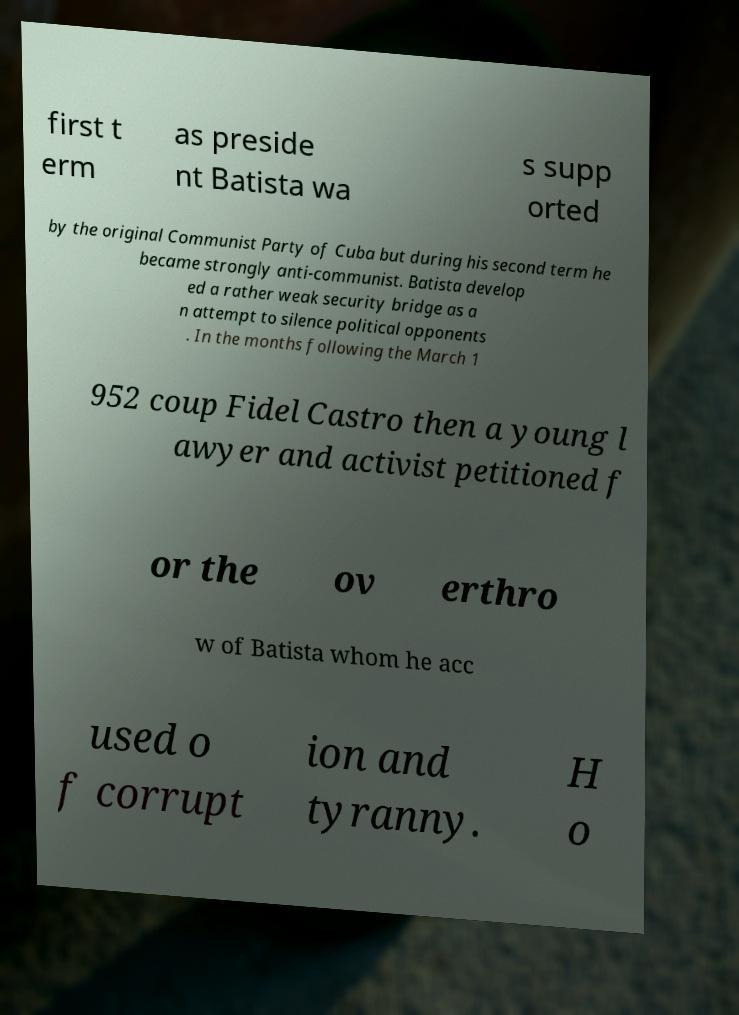Could you extract and type out the text from this image? first t erm as preside nt Batista wa s supp orted by the original Communist Party of Cuba but during his second term he became strongly anti-communist. Batista develop ed a rather weak security bridge as a n attempt to silence political opponents . In the months following the March 1 952 coup Fidel Castro then a young l awyer and activist petitioned f or the ov erthro w of Batista whom he acc used o f corrupt ion and tyranny. H o 